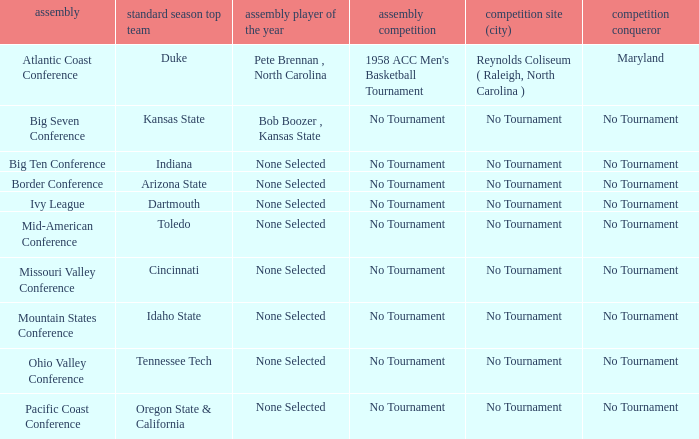What was the conference when Arizona State won the regular season? Border Conference. 